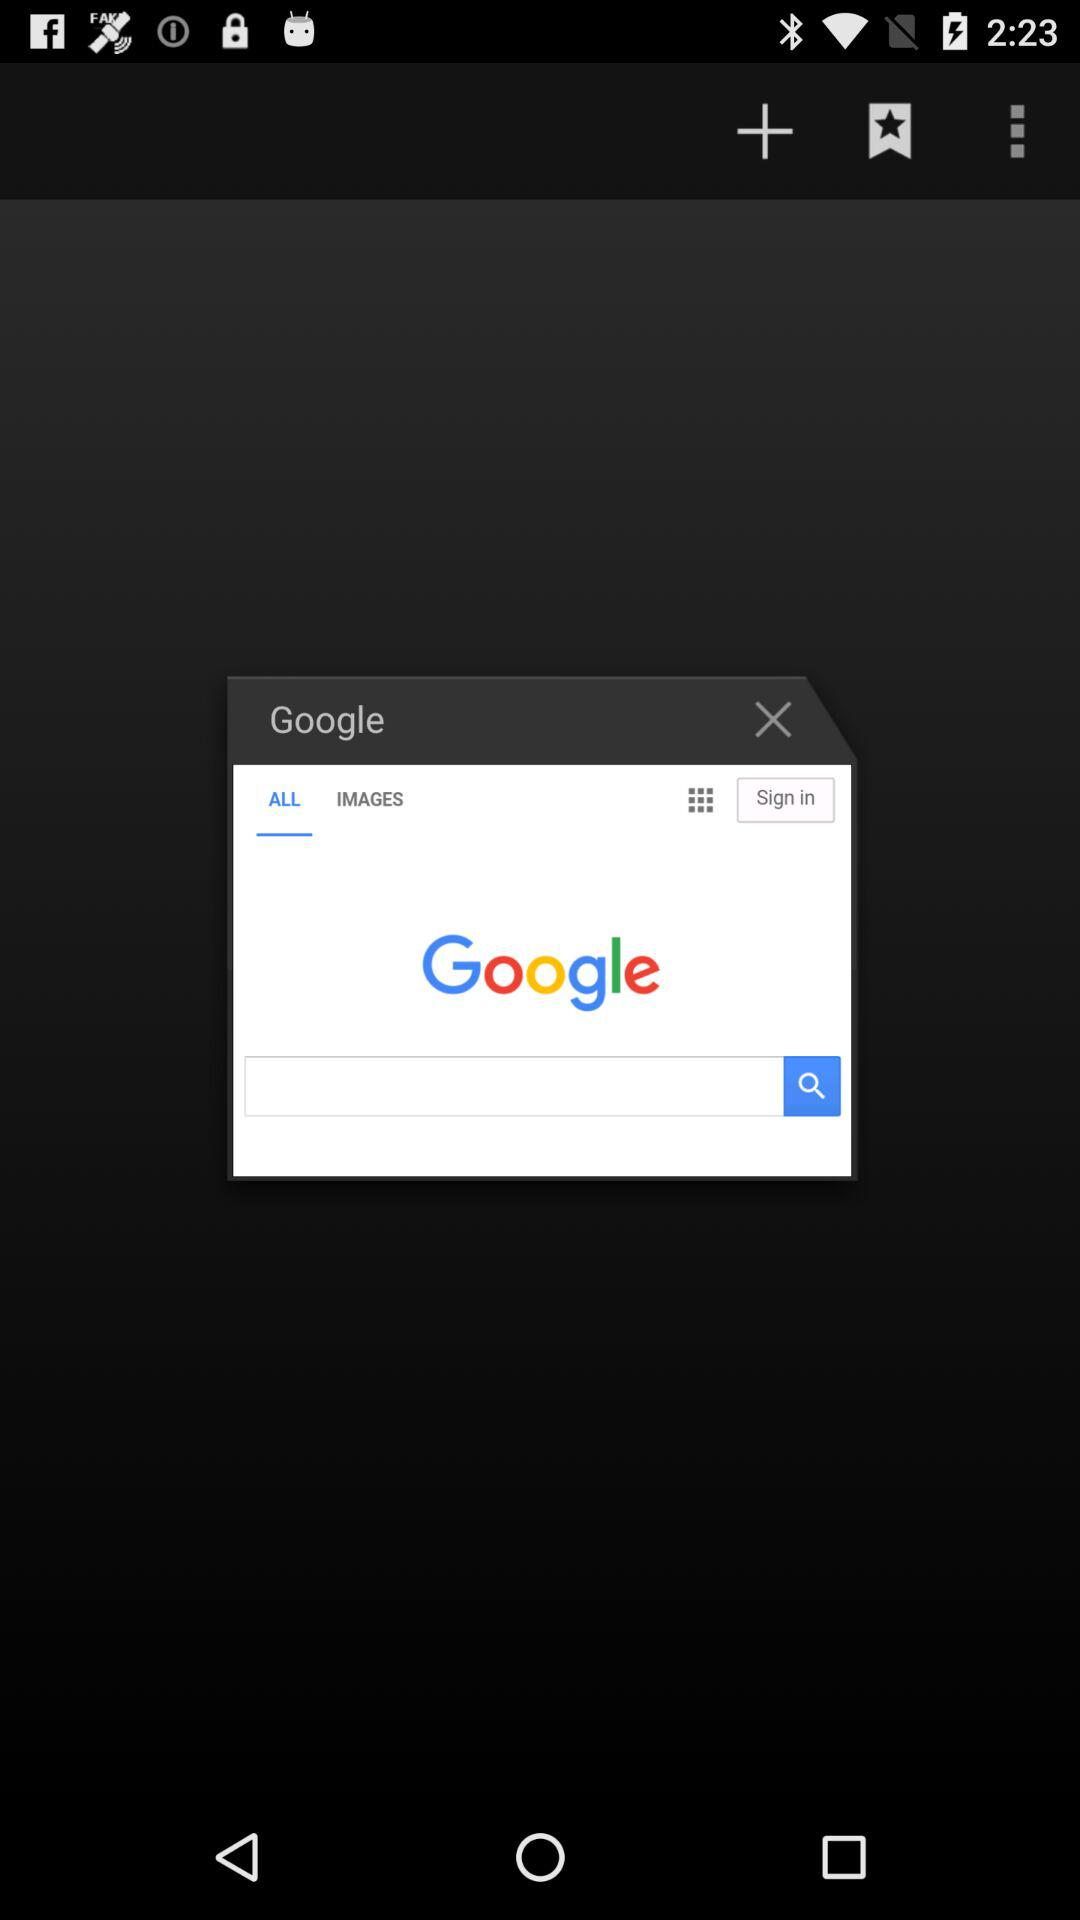How many text inputs are on the screen?
Answer the question using a single word or phrase. 1 